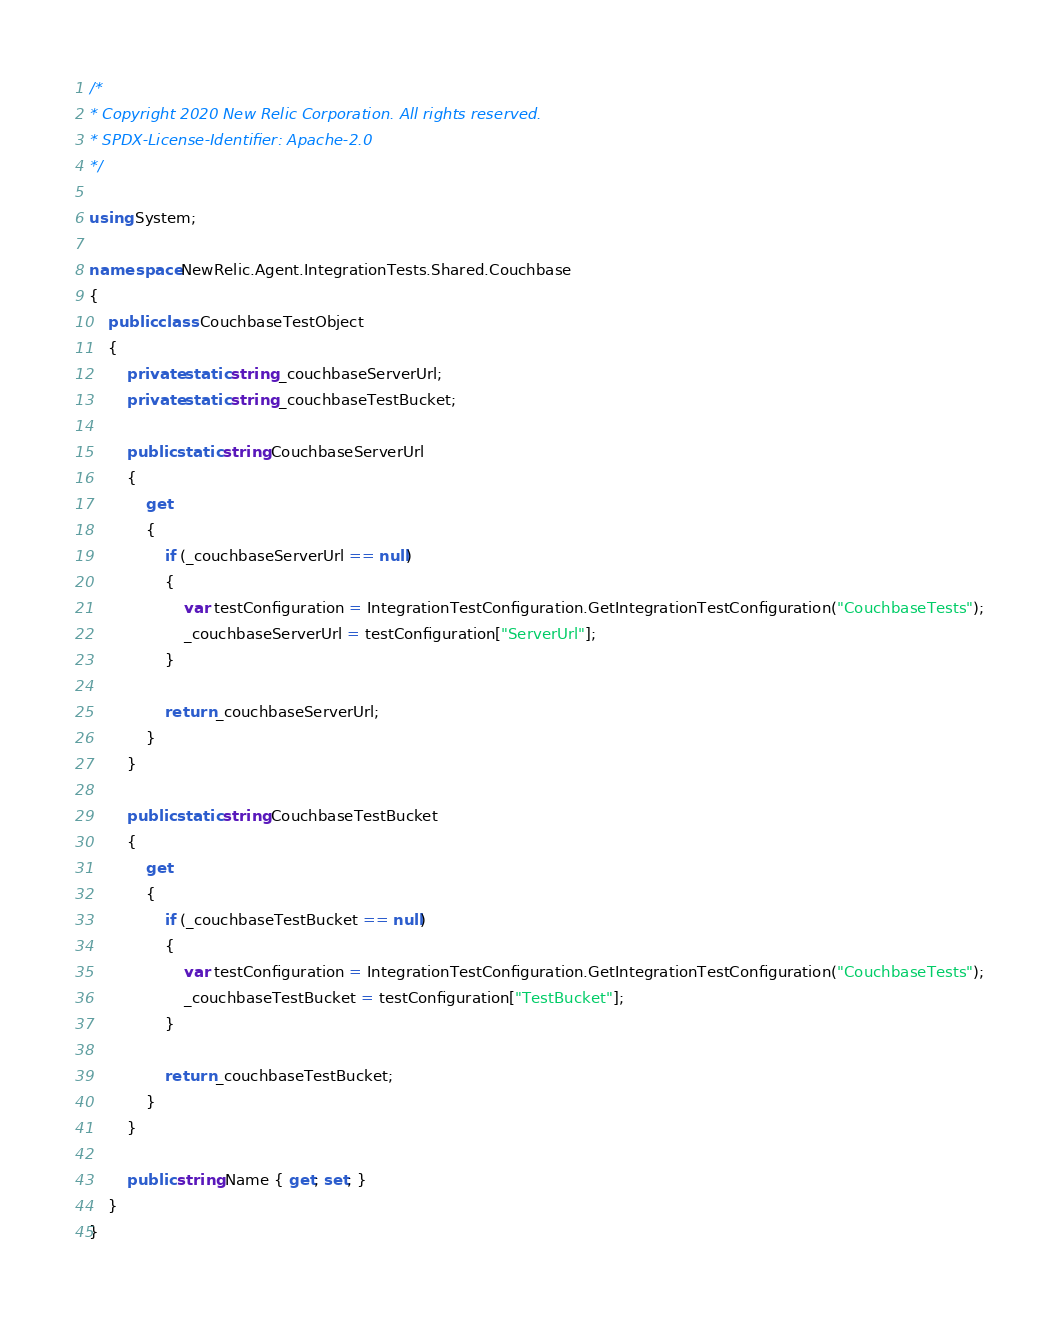Convert code to text. <code><loc_0><loc_0><loc_500><loc_500><_C#_>/*
* Copyright 2020 New Relic Corporation. All rights reserved.
* SPDX-License-Identifier: Apache-2.0
*/

using System;

namespace NewRelic.Agent.IntegrationTests.Shared.Couchbase
{
    public class CouchbaseTestObject
    {
        private static string _couchbaseServerUrl;
        private static string _couchbaseTestBucket;

        public static string CouchbaseServerUrl
        {
            get
            {
                if (_couchbaseServerUrl == null)
                {
                    var testConfiguration = IntegrationTestConfiguration.GetIntegrationTestConfiguration("CouchbaseTests");
                    _couchbaseServerUrl = testConfiguration["ServerUrl"];
                }

                return _couchbaseServerUrl;
            }
        }

        public static string CouchbaseTestBucket
        {
            get
            {
                if (_couchbaseTestBucket == null)
                {
                    var testConfiguration = IntegrationTestConfiguration.GetIntegrationTestConfiguration("CouchbaseTests");
                    _couchbaseTestBucket = testConfiguration["TestBucket"];
                }

                return _couchbaseTestBucket;
            }
        }

        public string Name { get; set; }
    }
}
</code> 